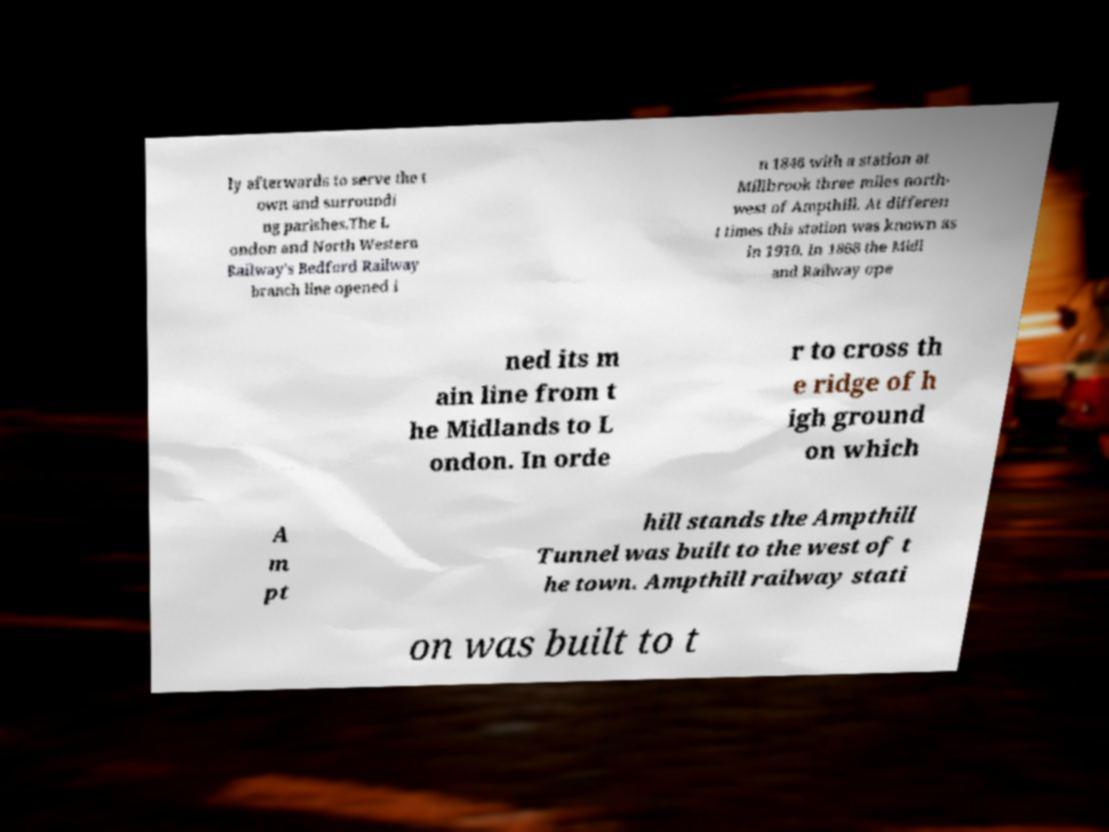Can you read and provide the text displayed in the image?This photo seems to have some interesting text. Can you extract and type it out for me? ly afterwards to serve the t own and surroundi ng parishes.The L ondon and North Western Railway's Bedford Railway branch line opened i n 1846 with a station at Millbrook three miles north- west of Ampthill. At differen t times this station was known as in 1910. In 1868 the Midl and Railway ope ned its m ain line from t he Midlands to L ondon. In orde r to cross th e ridge of h igh ground on which A m pt hill stands the Ampthill Tunnel was built to the west of t he town. Ampthill railway stati on was built to t 